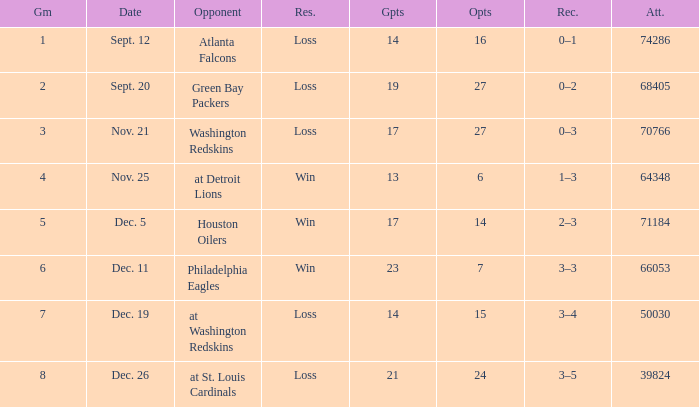What is the minimum number of opponents? 6.0. 